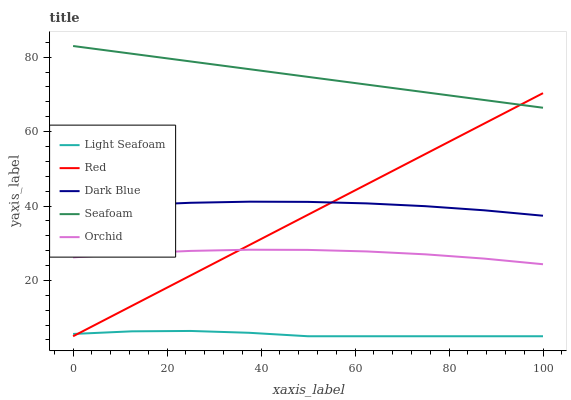Does Light Seafoam have the minimum area under the curve?
Answer yes or no. Yes. Does Seafoam have the maximum area under the curve?
Answer yes or no. Yes. Does Seafoam have the minimum area under the curve?
Answer yes or no. No. Does Light Seafoam have the maximum area under the curve?
Answer yes or no. No. Is Red the smoothest?
Answer yes or no. Yes. Is Orchid the roughest?
Answer yes or no. Yes. Is Light Seafoam the smoothest?
Answer yes or no. No. Is Light Seafoam the roughest?
Answer yes or no. No. Does Light Seafoam have the lowest value?
Answer yes or no. Yes. Does Seafoam have the lowest value?
Answer yes or no. No. Does Seafoam have the highest value?
Answer yes or no. Yes. Does Light Seafoam have the highest value?
Answer yes or no. No. Is Light Seafoam less than Orchid?
Answer yes or no. Yes. Is Dark Blue greater than Orchid?
Answer yes or no. Yes. Does Light Seafoam intersect Red?
Answer yes or no. Yes. Is Light Seafoam less than Red?
Answer yes or no. No. Is Light Seafoam greater than Red?
Answer yes or no. No. Does Light Seafoam intersect Orchid?
Answer yes or no. No. 